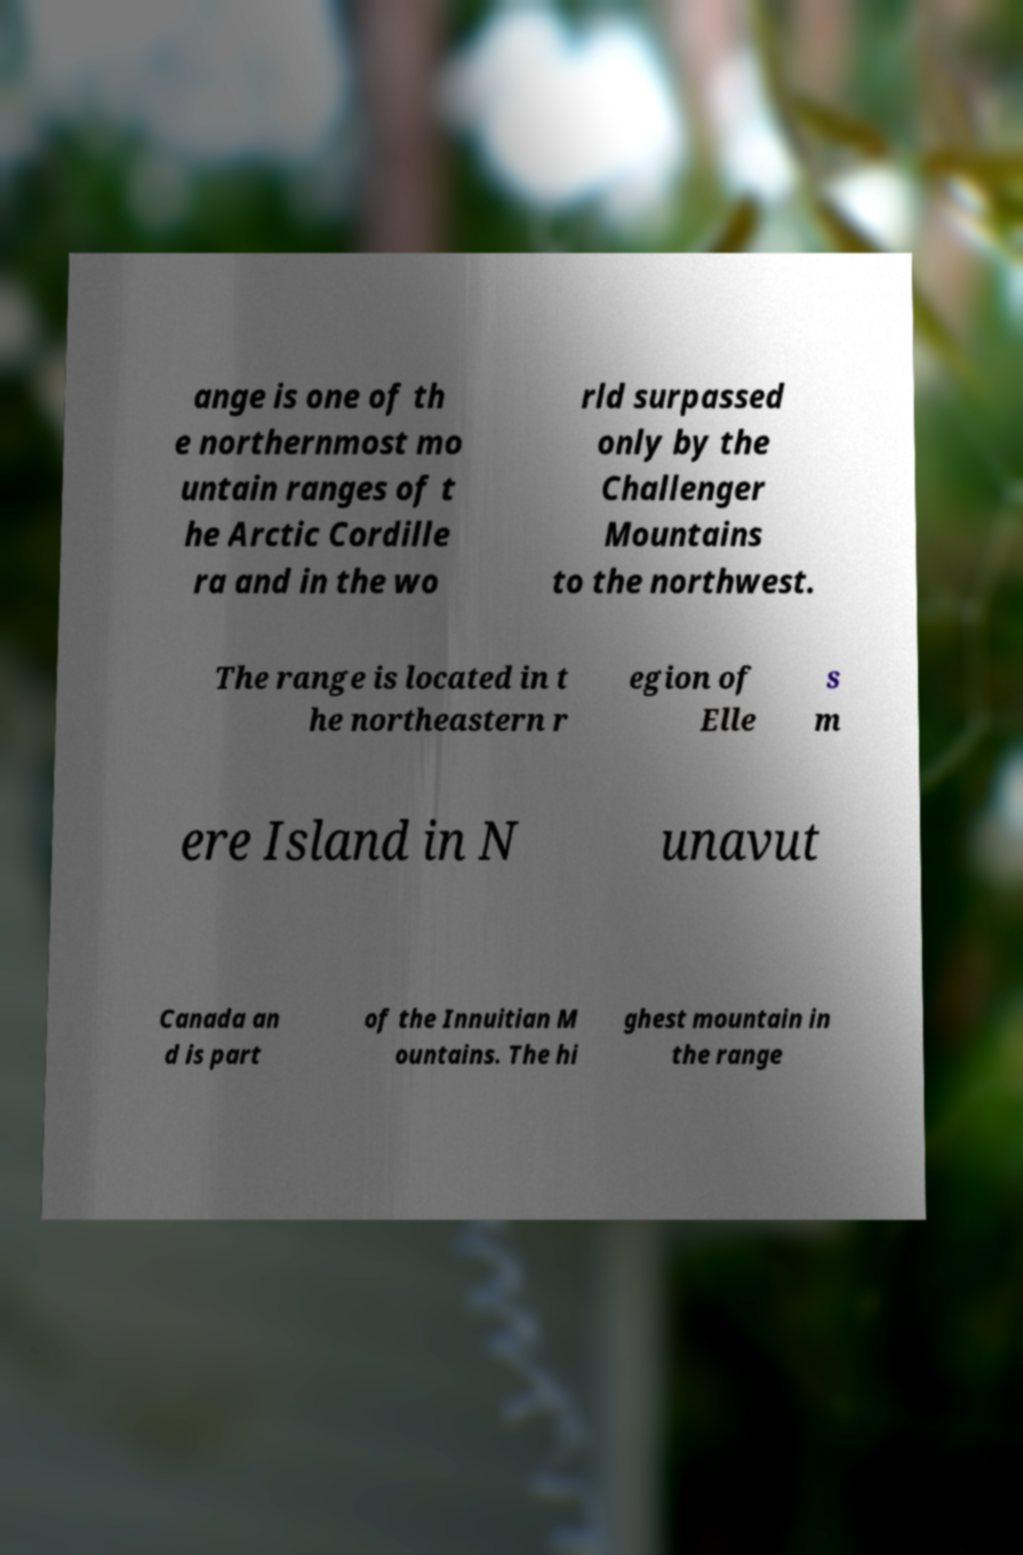For documentation purposes, I need the text within this image transcribed. Could you provide that? ange is one of th e northernmost mo untain ranges of t he Arctic Cordille ra and in the wo rld surpassed only by the Challenger Mountains to the northwest. The range is located in t he northeastern r egion of Elle s m ere Island in N unavut Canada an d is part of the Innuitian M ountains. The hi ghest mountain in the range 